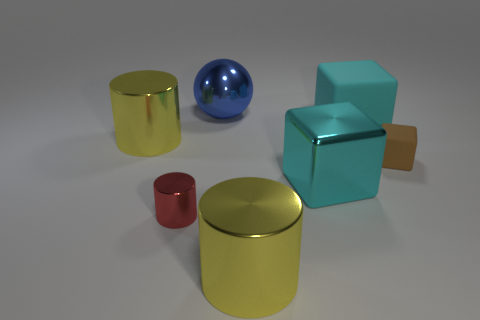Is there anything else that is made of the same material as the ball?
Ensure brevity in your answer.  Yes. How many things are either large yellow cylinders to the right of the big blue shiny object or small purple matte cubes?
Provide a short and direct response. 1. There is a large cyan block that is right of the cube that is left of the large cyan rubber thing; are there any big things that are on the right side of it?
Ensure brevity in your answer.  No. Are there the same number of large objects and red shiny things?
Your response must be concise. No. What number of large blue metallic cylinders are there?
Provide a succinct answer. 0. What number of things are either large yellow metallic cylinders that are in front of the big metallic block or large cylinders in front of the brown block?
Ensure brevity in your answer.  1. There is a yellow metal cylinder that is right of the blue object; is its size the same as the tiny red metallic cylinder?
Your answer should be compact. No. The cyan shiny thing that is the same shape as the small brown rubber thing is what size?
Your response must be concise. Large. What material is the other thing that is the same size as the brown object?
Keep it short and to the point. Metal. There is another cyan object that is the same shape as the large cyan rubber thing; what material is it?
Your response must be concise. Metal. 